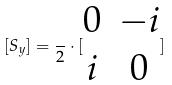Convert formula to latex. <formula><loc_0><loc_0><loc_500><loc_500>[ S _ { y } ] = \frac { } { 2 } \cdot [ \begin{matrix} 0 & - i \\ i & 0 \end{matrix} ]</formula> 